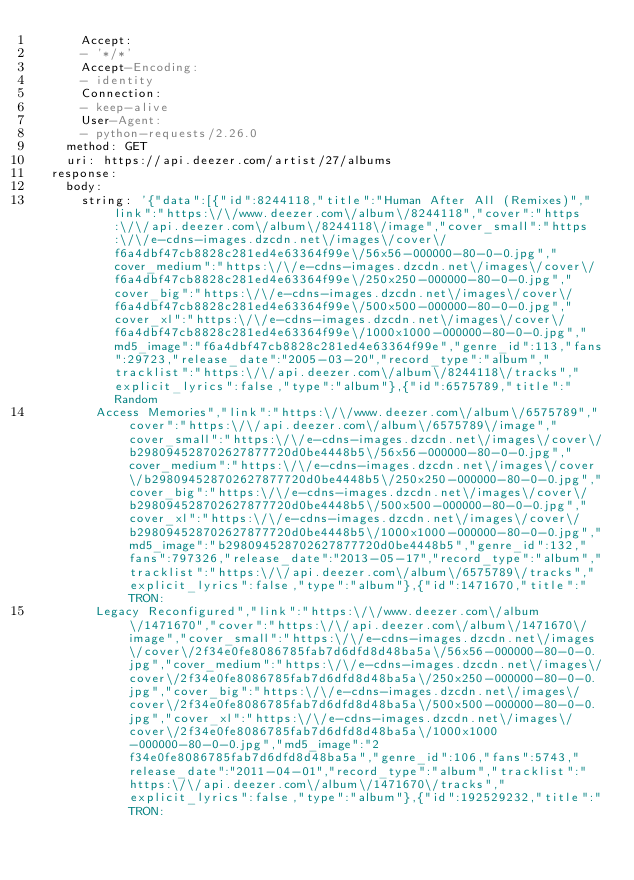Convert code to text. <code><loc_0><loc_0><loc_500><loc_500><_YAML_>      Accept:
      - '*/*'
      Accept-Encoding:
      - identity
      Connection:
      - keep-alive
      User-Agent:
      - python-requests/2.26.0
    method: GET
    uri: https://api.deezer.com/artist/27/albums
  response:
    body:
      string: '{"data":[{"id":8244118,"title":"Human After All (Remixes)","link":"https:\/\/www.deezer.com\/album\/8244118","cover":"https:\/\/api.deezer.com\/album\/8244118\/image","cover_small":"https:\/\/e-cdns-images.dzcdn.net\/images\/cover\/f6a4dbf47cb8828c281ed4e63364f99e\/56x56-000000-80-0-0.jpg","cover_medium":"https:\/\/e-cdns-images.dzcdn.net\/images\/cover\/f6a4dbf47cb8828c281ed4e63364f99e\/250x250-000000-80-0-0.jpg","cover_big":"https:\/\/e-cdns-images.dzcdn.net\/images\/cover\/f6a4dbf47cb8828c281ed4e63364f99e\/500x500-000000-80-0-0.jpg","cover_xl":"https:\/\/e-cdns-images.dzcdn.net\/images\/cover\/f6a4dbf47cb8828c281ed4e63364f99e\/1000x1000-000000-80-0-0.jpg","md5_image":"f6a4dbf47cb8828c281ed4e63364f99e","genre_id":113,"fans":29723,"release_date":"2005-03-20","record_type":"album","tracklist":"https:\/\/api.deezer.com\/album\/8244118\/tracks","explicit_lyrics":false,"type":"album"},{"id":6575789,"title":"Random
        Access Memories","link":"https:\/\/www.deezer.com\/album\/6575789","cover":"https:\/\/api.deezer.com\/album\/6575789\/image","cover_small":"https:\/\/e-cdns-images.dzcdn.net\/images\/cover\/b298094528702627877720d0be4448b5\/56x56-000000-80-0-0.jpg","cover_medium":"https:\/\/e-cdns-images.dzcdn.net\/images\/cover\/b298094528702627877720d0be4448b5\/250x250-000000-80-0-0.jpg","cover_big":"https:\/\/e-cdns-images.dzcdn.net\/images\/cover\/b298094528702627877720d0be4448b5\/500x500-000000-80-0-0.jpg","cover_xl":"https:\/\/e-cdns-images.dzcdn.net\/images\/cover\/b298094528702627877720d0be4448b5\/1000x1000-000000-80-0-0.jpg","md5_image":"b298094528702627877720d0be4448b5","genre_id":132,"fans":797326,"release_date":"2013-05-17","record_type":"album","tracklist":"https:\/\/api.deezer.com\/album\/6575789\/tracks","explicit_lyrics":false,"type":"album"},{"id":1471670,"title":"TRON:
        Legacy Reconfigured","link":"https:\/\/www.deezer.com\/album\/1471670","cover":"https:\/\/api.deezer.com\/album\/1471670\/image","cover_small":"https:\/\/e-cdns-images.dzcdn.net\/images\/cover\/2f34e0fe8086785fab7d6dfd8d48ba5a\/56x56-000000-80-0-0.jpg","cover_medium":"https:\/\/e-cdns-images.dzcdn.net\/images\/cover\/2f34e0fe8086785fab7d6dfd8d48ba5a\/250x250-000000-80-0-0.jpg","cover_big":"https:\/\/e-cdns-images.dzcdn.net\/images\/cover\/2f34e0fe8086785fab7d6dfd8d48ba5a\/500x500-000000-80-0-0.jpg","cover_xl":"https:\/\/e-cdns-images.dzcdn.net\/images\/cover\/2f34e0fe8086785fab7d6dfd8d48ba5a\/1000x1000-000000-80-0-0.jpg","md5_image":"2f34e0fe8086785fab7d6dfd8d48ba5a","genre_id":106,"fans":5743,"release_date":"2011-04-01","record_type":"album","tracklist":"https:\/\/api.deezer.com\/album\/1471670\/tracks","explicit_lyrics":false,"type":"album"},{"id":192529232,"title":"TRON:</code> 